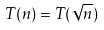Convert formula to latex. <formula><loc_0><loc_0><loc_500><loc_500>T ( n ) = T ( \sqrt { n } )</formula> 